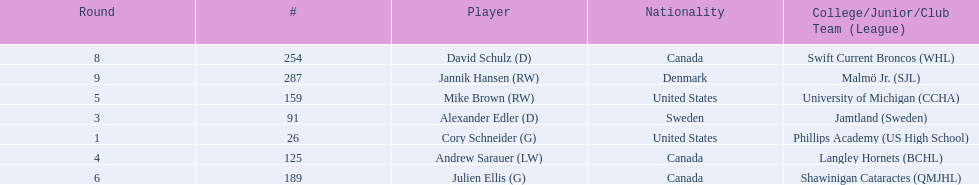Who are the players? Cory Schneider (G), Alexander Edler (D), Andrew Sarauer (LW), Mike Brown (RW), Julien Ellis (G), David Schulz (D), Jannik Hansen (RW). Of those, who is from denmark? Jannik Hansen (RW). 